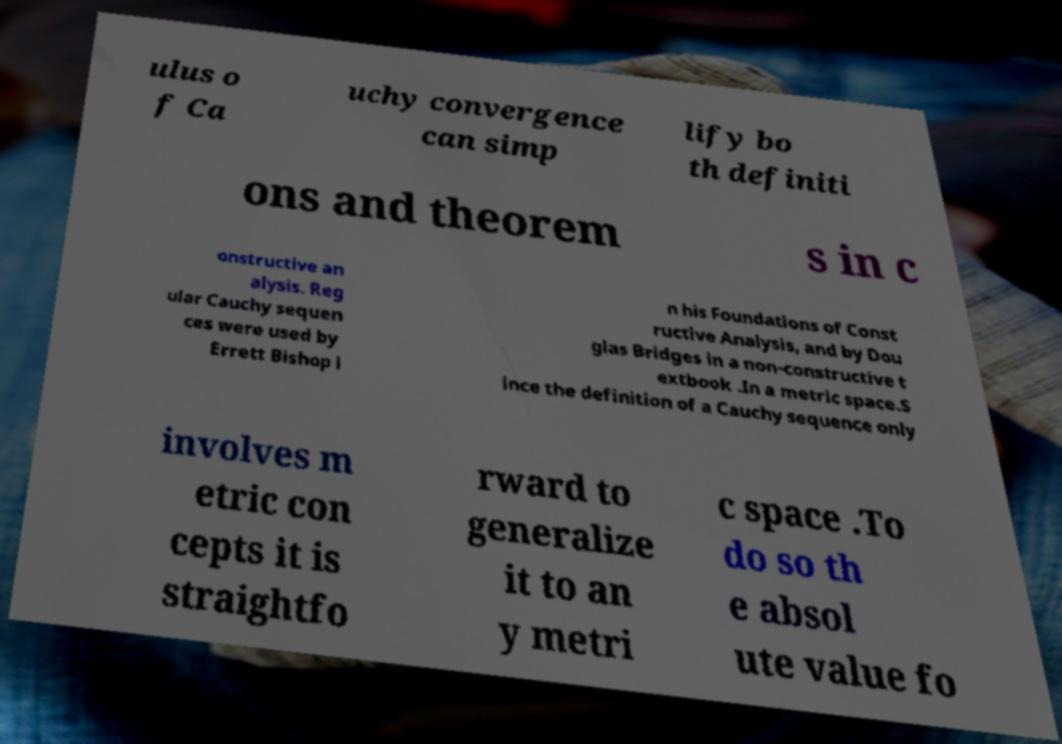Could you extract and type out the text from this image? ulus o f Ca uchy convergence can simp lify bo th definiti ons and theorem s in c onstructive an alysis. Reg ular Cauchy sequen ces were used by Errett Bishop i n his Foundations of Const ructive Analysis, and by Dou glas Bridges in a non-constructive t extbook .In a metric space.S ince the definition of a Cauchy sequence only involves m etric con cepts it is straightfo rward to generalize it to an y metri c space .To do so th e absol ute value fo 